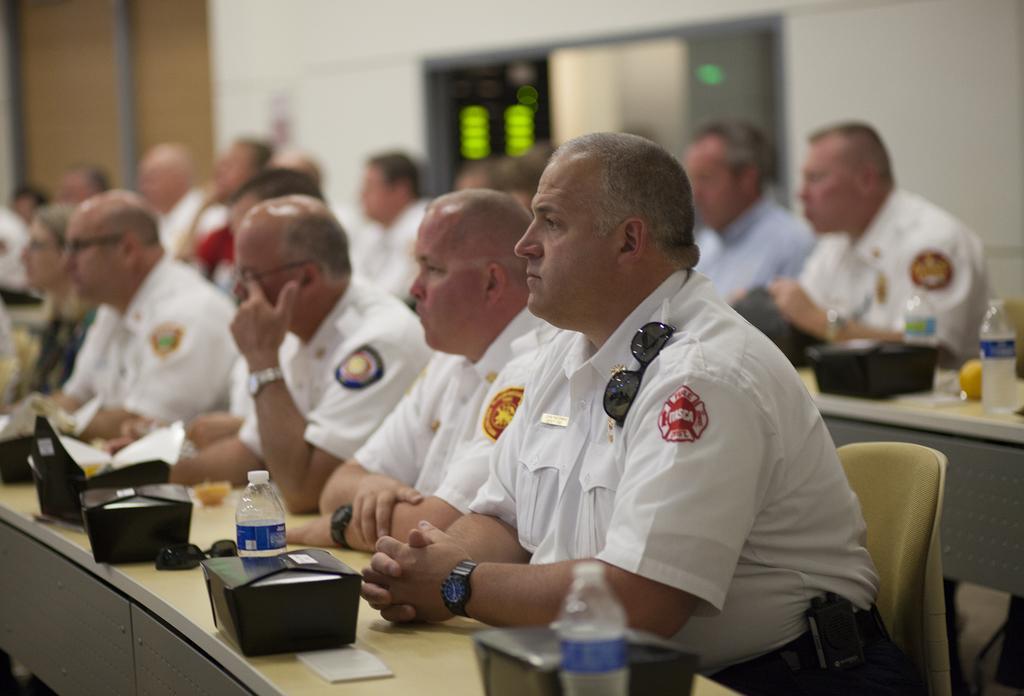Could you give a brief overview of what you see in this image? In this picture I can see few people seated and I can see few water bottles, papers and few boxes on the tables and looks like a door in the back. 